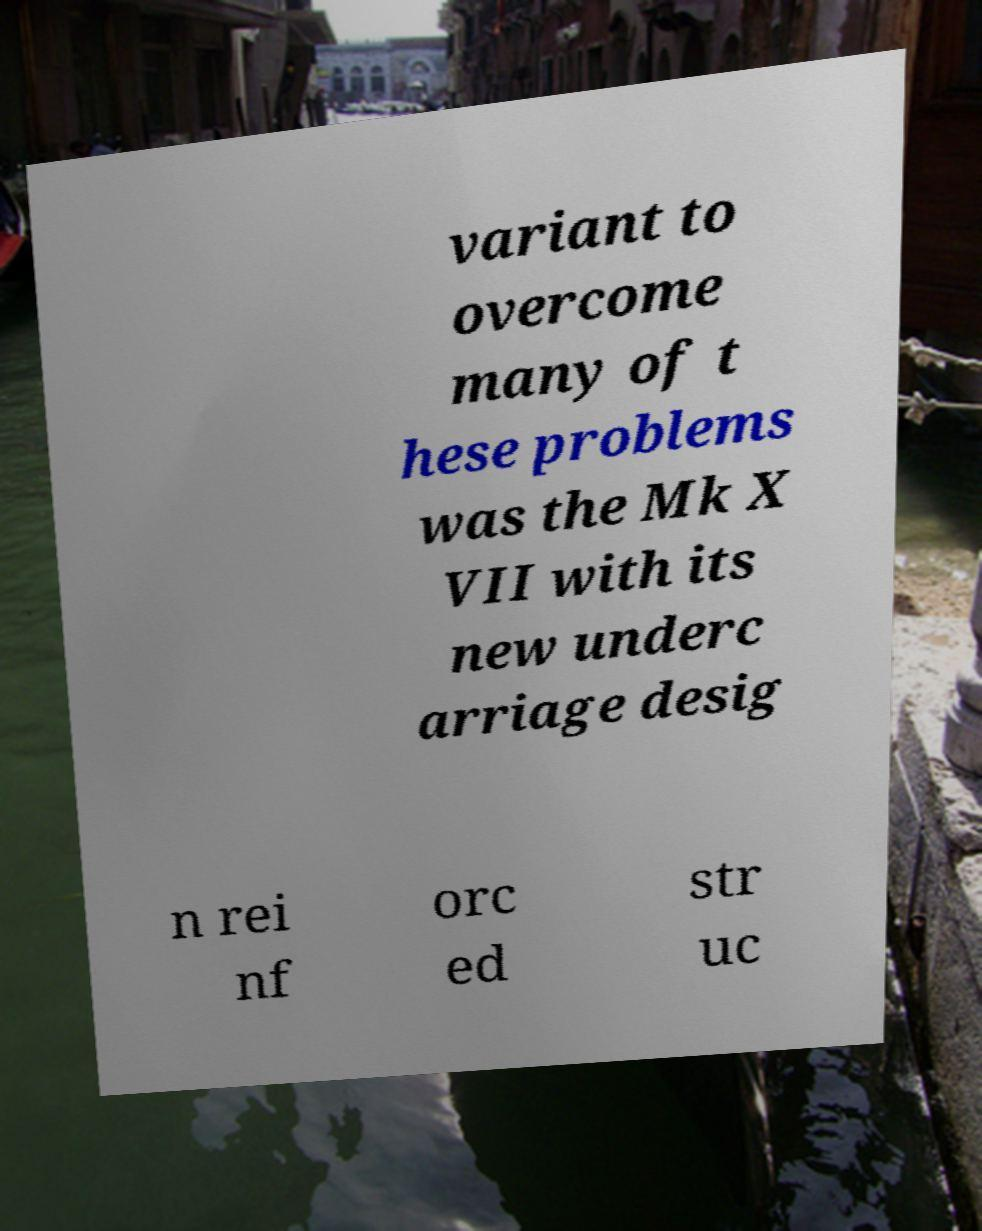Please identify and transcribe the text found in this image. variant to overcome many of t hese problems was the Mk X VII with its new underc arriage desig n rei nf orc ed str uc 